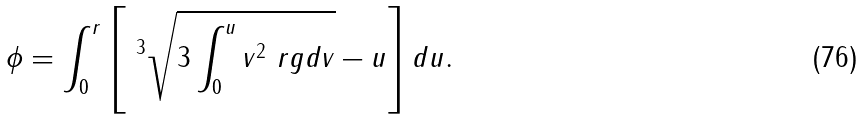Convert formula to latex. <formula><loc_0><loc_0><loc_500><loc_500>\phi = \int _ { 0 } ^ { r } \left [ \ ^ { 3 } \sqrt { 3 \int _ { 0 } ^ { u } v ^ { 2 } \ r g d v } - u \right ] d u .</formula> 